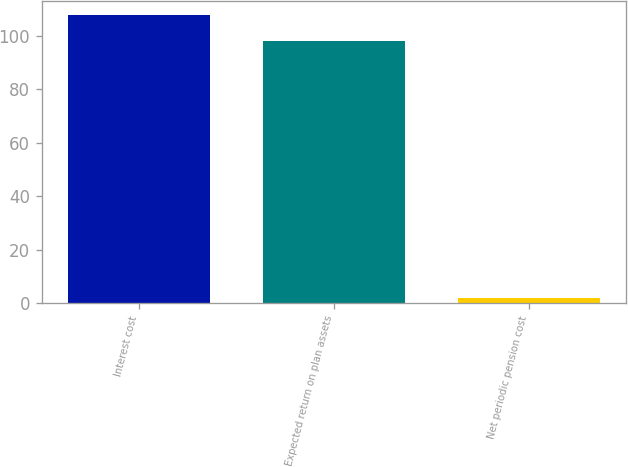Convert chart. <chart><loc_0><loc_0><loc_500><loc_500><bar_chart><fcel>Interest cost<fcel>Expected return on plan assets<fcel>Net periodic pension cost<nl><fcel>107.8<fcel>98<fcel>2<nl></chart> 